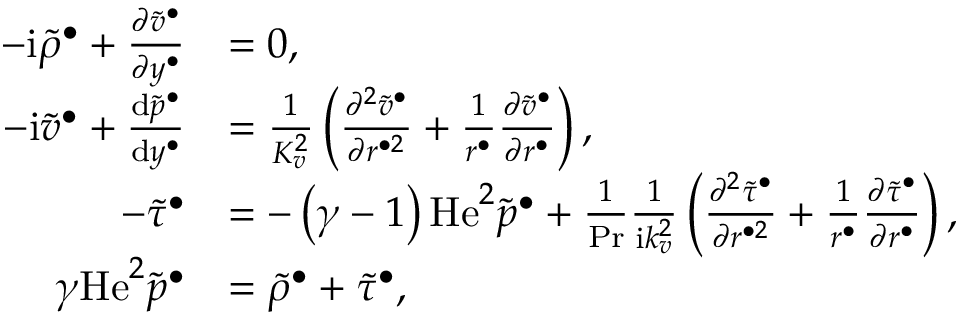<formula> <loc_0><loc_0><loc_500><loc_500>\begin{array} { r l } { - i \widetilde { \rho } ^ { \bullet } + \frac { \partial \widetilde { v } ^ { \bullet } } { \partial y ^ { \bullet } } } & { = 0 , } \\ { - i \widetilde { v } ^ { \bullet } + \frac { d \widetilde { p } ^ { \bullet } } { d y ^ { \bullet } } } & { = \frac { 1 } { K _ { v } ^ { 2 } } \left ( \frac { \partial ^ { 2 } \widetilde { v } ^ { \bullet } } { \partial r ^ { \bullet 2 } } + \frac { 1 } { r ^ { \bullet } } \frac { \partial \widetilde { v } ^ { \bullet } } { \partial r ^ { \bullet } } \right ) , } \\ { - \widetilde { \tau } ^ { \bullet } } & { = - \left ( \gamma - 1 \right ) H e ^ { 2 } \widetilde { p } ^ { \bullet } + \frac { 1 } { P r } \frac { 1 } { i k _ { v } ^ { 2 } } \left ( \frac { \partial ^ { 2 } \widetilde { \tau } ^ { \bullet } } { \partial r ^ { \bullet 2 } } + \frac { 1 } { r ^ { \bullet } } \frac { \partial \widetilde { \tau } ^ { \bullet } } { \partial r ^ { \bullet } } \right ) , } \\ { \gamma H e ^ { 2 } \widetilde { p } ^ { \bullet } } & { = \widetilde { \rho } ^ { \bullet } + \widetilde { \tau } ^ { \bullet } , } \end{array}</formula> 